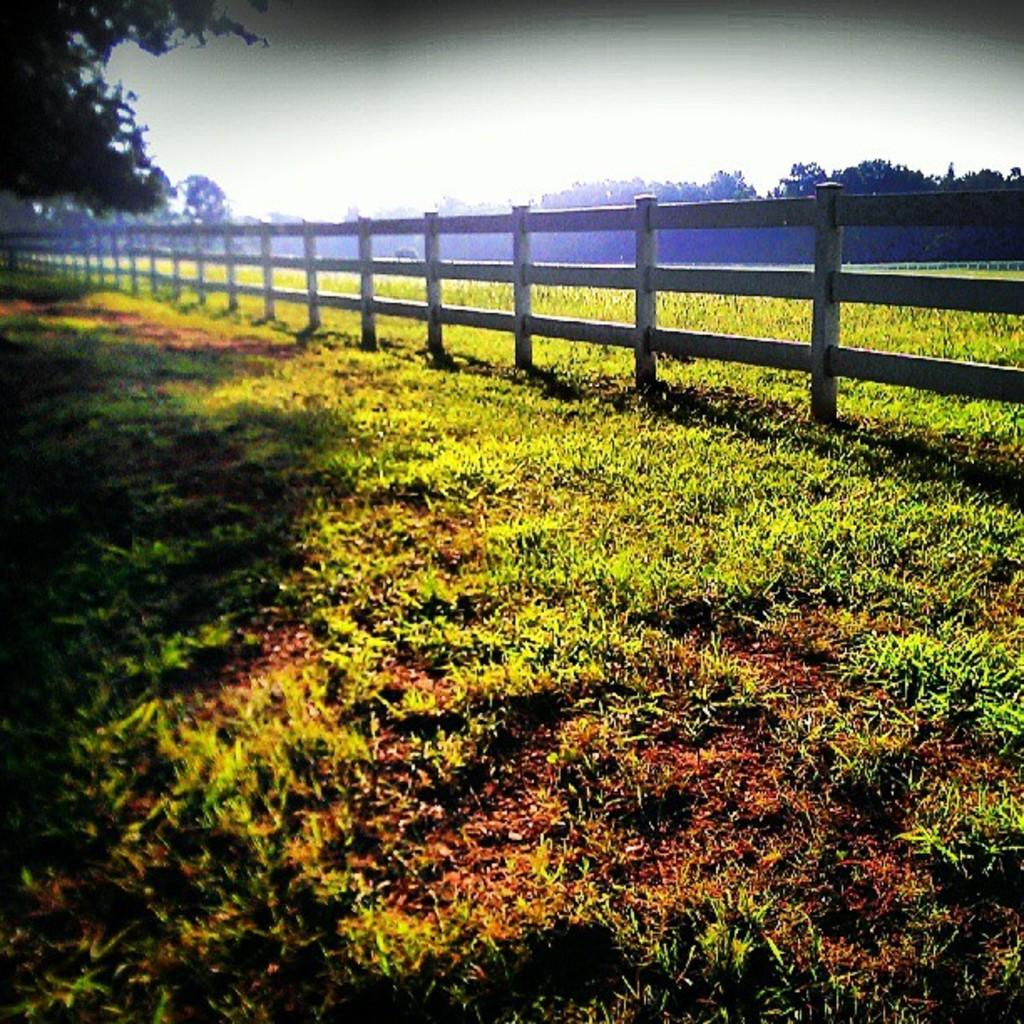What is located in the center of the image? There is a metal fence in the center of the image. What type of surface is at the bottom of the image? There is grass on the surface at the bottom of the image. What can be seen in the background of the image? There are trees and the sky visible in the background of the image. How many chickens are standing on the metal fence in the image? There are no chickens present in the image. What type of border does the metal fence represent in the image? The metal fence does not represent a border in the image; it is simply a fence. 